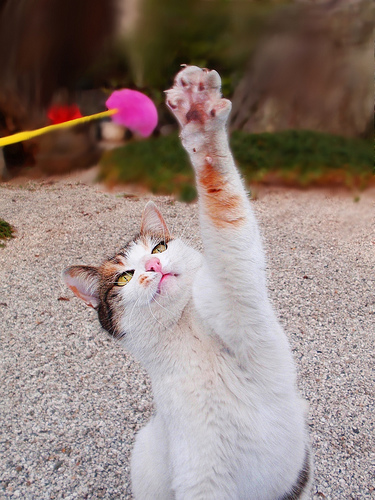<image>
Is there a nails in the paw? Yes. The nails is contained within or inside the paw, showing a containment relationship. Is there a cat on the grass? No. The cat is not positioned on the grass. They may be near each other, but the cat is not supported by or resting on top of the grass. Is there a cat paw to the right of the cat toy? Yes. From this viewpoint, the cat paw is positioned to the right side relative to the cat toy. 